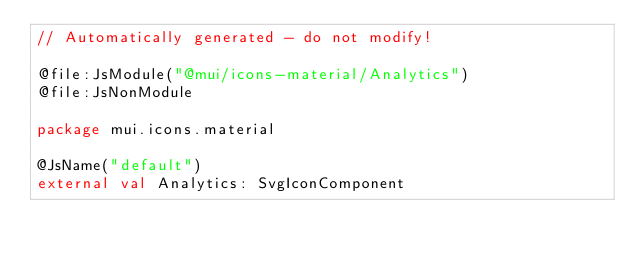Convert code to text. <code><loc_0><loc_0><loc_500><loc_500><_Kotlin_>// Automatically generated - do not modify!

@file:JsModule("@mui/icons-material/Analytics")
@file:JsNonModule

package mui.icons.material

@JsName("default")
external val Analytics: SvgIconComponent
</code> 